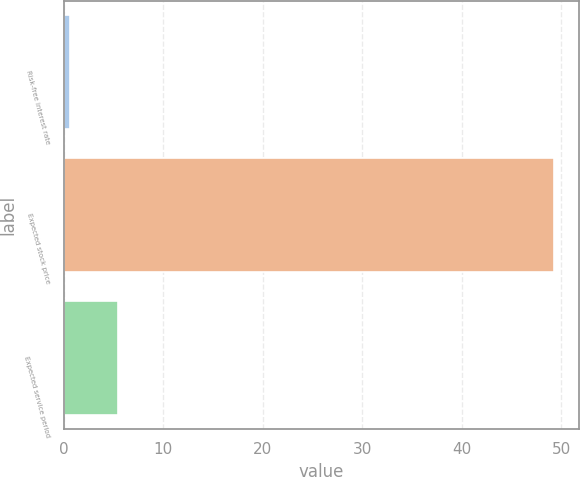Convert chart. <chart><loc_0><loc_0><loc_500><loc_500><bar_chart><fcel>Risk-free interest rate<fcel>Expected stock price<fcel>Expected service period<nl><fcel>0.6<fcel>49.3<fcel>5.47<nl></chart> 